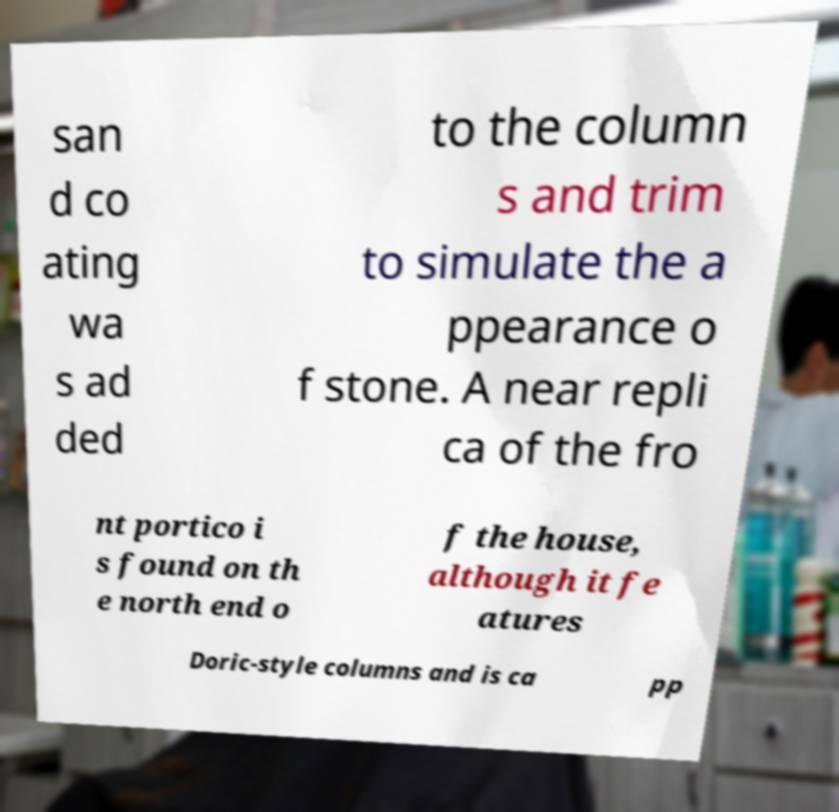Can you accurately transcribe the text from the provided image for me? san d co ating wa s ad ded to the column s and trim to simulate the a ppearance o f stone. A near repli ca of the fro nt portico i s found on th e north end o f the house, although it fe atures Doric-style columns and is ca pp 